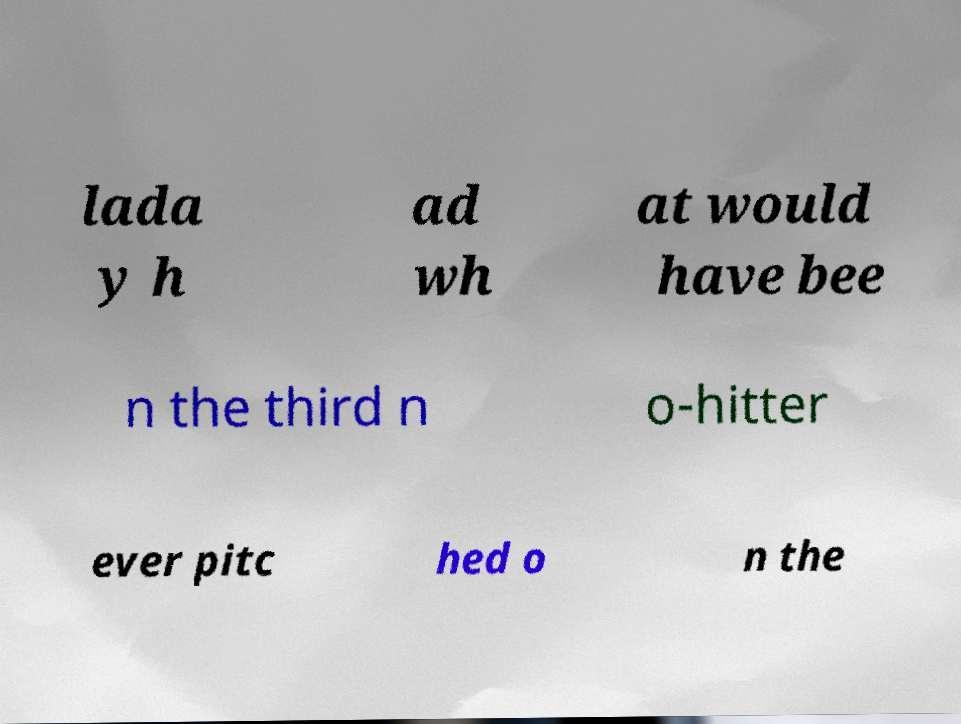Can you accurately transcribe the text from the provided image for me? lada y h ad wh at would have bee n the third n o-hitter ever pitc hed o n the 